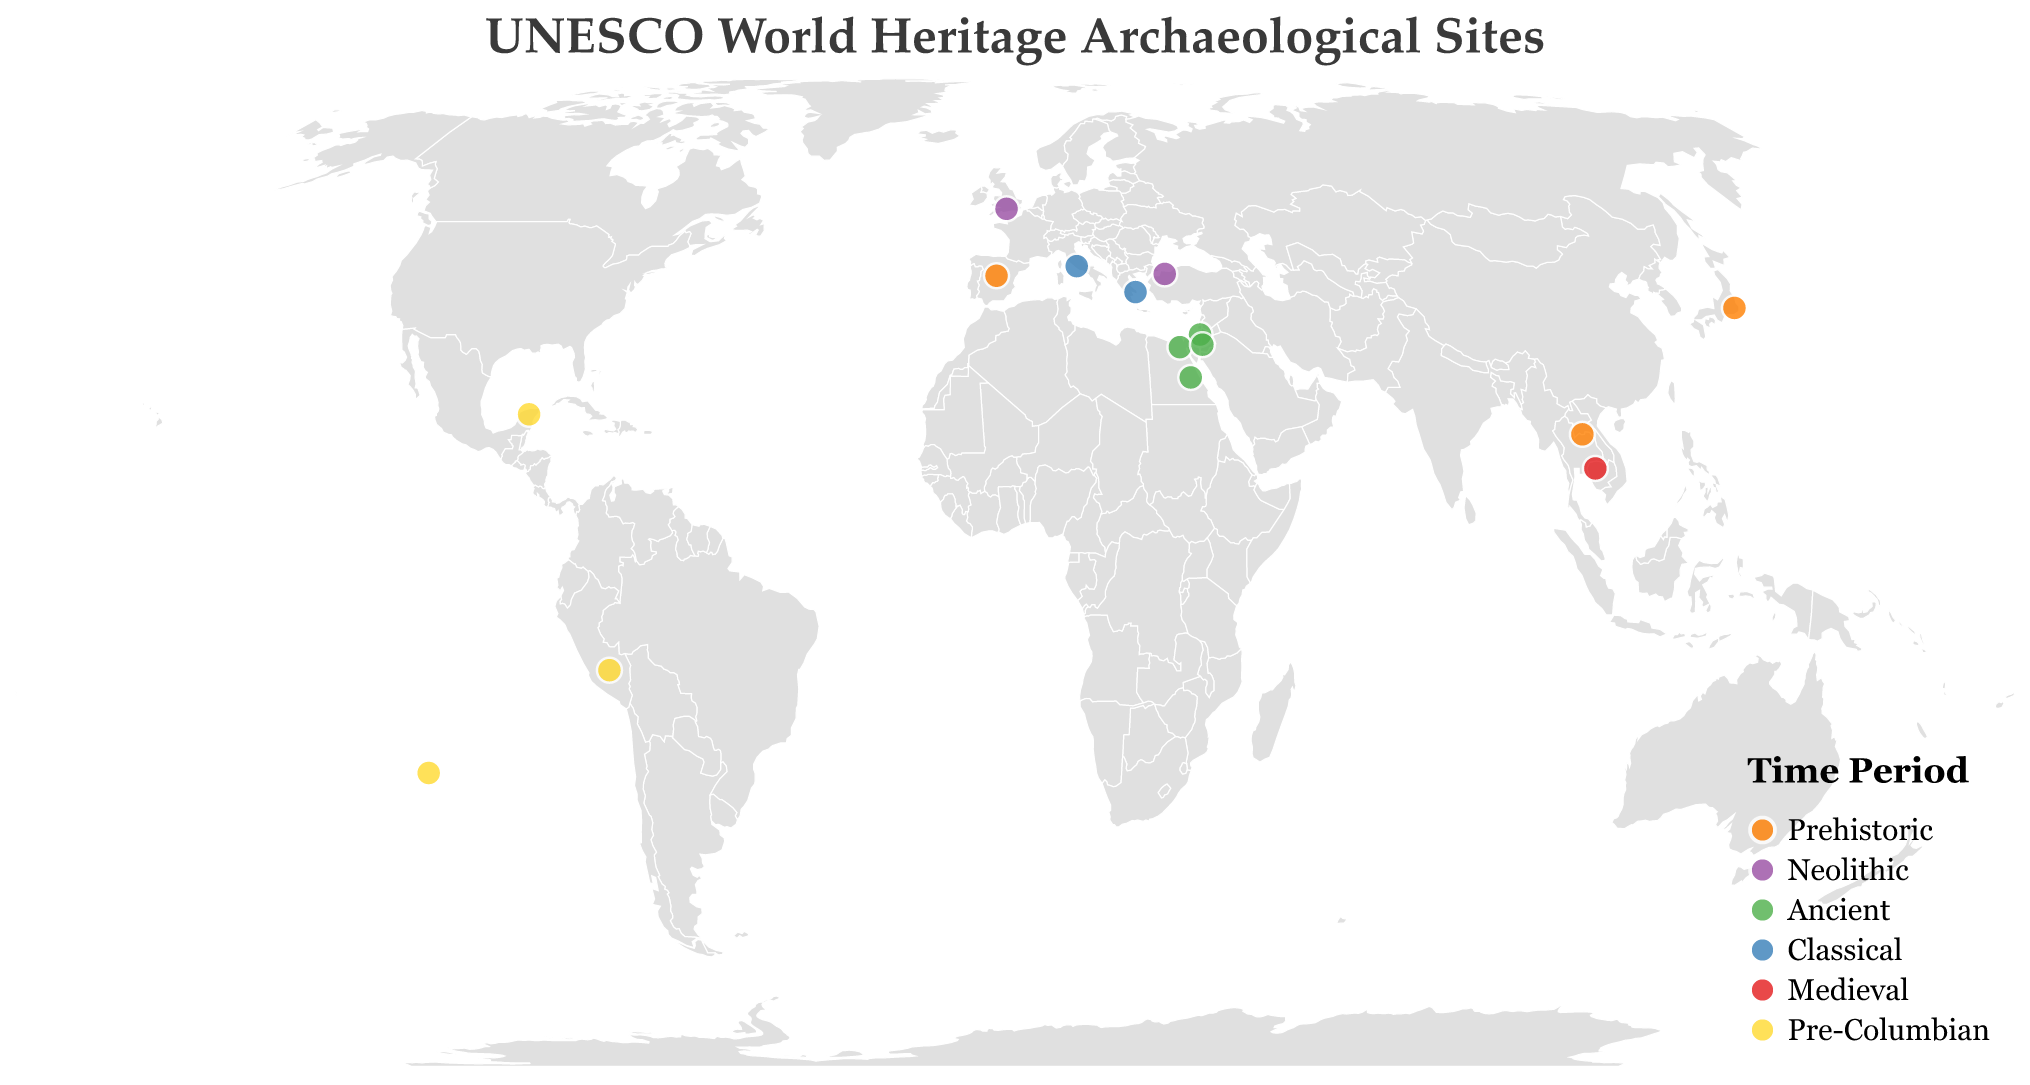Where is the Acropolis of Athens located? The tooltip for the Acropolis of Athens shows that it is located at latitude 37.9715 and longitude 23.7267.
Answer: Greece Which site represents the Medieval period? By referring to the color legend and matching the corresponding color with the plotted points, "Angkor Archaeological Park" in Cambodia represents the Medieval period.
Answer: Angkor Archaeological Park How many sites are categorized under the Prehistoric period? By counting the number of points colored according to the Prehistoric category represented in the legend, there are 4 sites.
Answer: 4 What common feature do the sites in Egypt share based on the time period? Referring to the plotted points in Egypt and their tooltip information reveals that both sites (Pyramids of Giza and Ancient Thebes with its Necropolis) fall under the 'Ancient' time period.
Answer: Ancient Which country has the highest number of archaeological sites mentioned in the figure? By looking at the tooltip information for all plotted points, Egypt and Spain both have 2 sites each.
Answer: Egypt and Spain Compare the distribution of sites in the Classical period with those in the Pre-Columbian period. Which is more widespread globally? The Classical period has sites in Italy and Greece. The Pre-Columbian period has sites in Mexico, Peru, and Chile. The Pre-Columbian sites are more globally widespread because they span multiple continents, while Classical sites are concentrated in Europe.
Answer: Pre-Columbian Which archaeological site is furthest south on the map? By observing the geographic plot and finding the site with the smallest latitude value, "Rapa Nui National Park" in Chile is the furthest south.
Answer: Rapa Nui National Park How many sites are located in Asia? By counting the number of sites falling within the geographic bounds of Asia (e.g., Jordan, Israel, Japan, Laos, and Cambodia), there are 5 sites.
Answer: 5 What are the coordinates of the Neolithic site located in Turkey? The tooltip for the Neolithic site of Çatalhöyük in Turkey indicates its coordinates as latitude 40.7115 and longitude 29.9764.
Answer: 40.7115, 29.9764 Which sites fall under the 'Ancient' period and in which countries are they located? By matching the color for the 'Ancient' period in the legend with the plotted points, the sites are: Old City of Jerusalem (Israel), Pyramids of Giza (Egypt), Petra Archaeological Park (Jordan), and Ancient Thebes with its Necropolis (Egypt).
Answer: Israel, Egypt, Jordan 